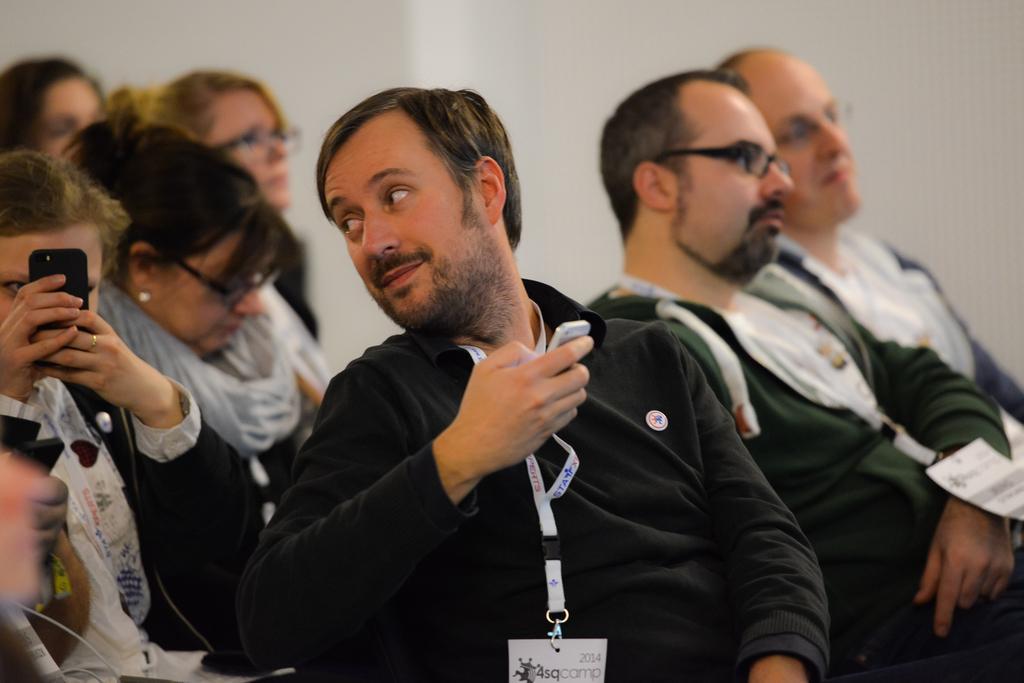Could you give a brief overview of what you see in this image? This is an inside view. Here I can see few people sitting facing towards the right side. There is a man holding a mobile in the hand and looking at the woman who is on the left side. This woman is holding a mobile in the hands and looking into the mobile. In the background there is a wall. 